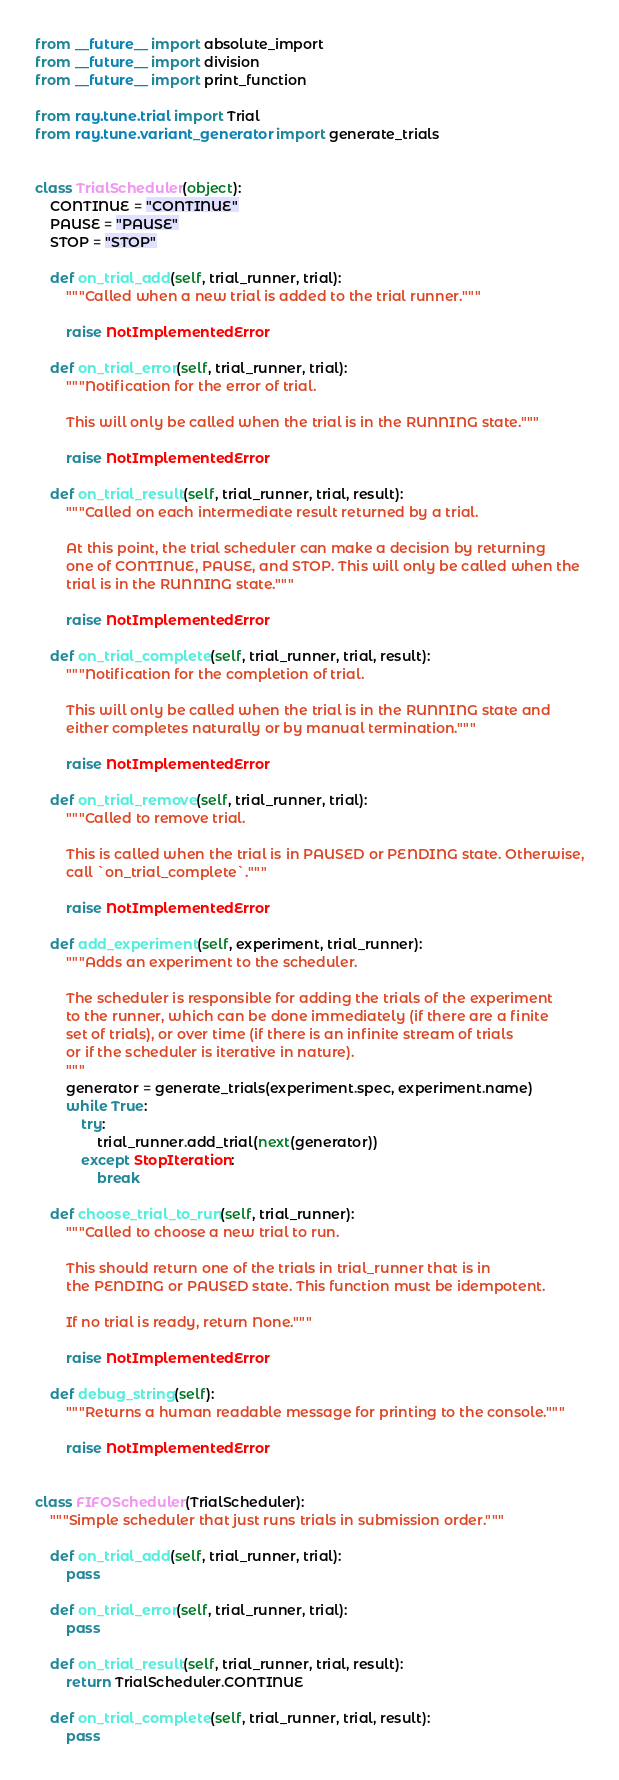<code> <loc_0><loc_0><loc_500><loc_500><_Python_>from __future__ import absolute_import
from __future__ import division
from __future__ import print_function

from ray.tune.trial import Trial
from ray.tune.variant_generator import generate_trials


class TrialScheduler(object):
    CONTINUE = "CONTINUE"
    PAUSE = "PAUSE"
    STOP = "STOP"

    def on_trial_add(self, trial_runner, trial):
        """Called when a new trial is added to the trial runner."""

        raise NotImplementedError

    def on_trial_error(self, trial_runner, trial):
        """Notification for the error of trial.

        This will only be called when the trial is in the RUNNING state."""

        raise NotImplementedError

    def on_trial_result(self, trial_runner, trial, result):
        """Called on each intermediate result returned by a trial.

        At this point, the trial scheduler can make a decision by returning
        one of CONTINUE, PAUSE, and STOP. This will only be called when the
        trial is in the RUNNING state."""

        raise NotImplementedError

    def on_trial_complete(self, trial_runner, trial, result):
        """Notification for the completion of trial.

        This will only be called when the trial is in the RUNNING state and
        either completes naturally or by manual termination."""

        raise NotImplementedError

    def on_trial_remove(self, trial_runner, trial):
        """Called to remove trial.

        This is called when the trial is in PAUSED or PENDING state. Otherwise,
        call `on_trial_complete`."""

        raise NotImplementedError

    def add_experiment(self, experiment, trial_runner):
        """Adds an experiment to the scheduler.

        The scheduler is responsible for adding the trials of the experiment
        to the runner, which can be done immediately (if there are a finite
        set of trials), or over time (if there is an infinite stream of trials
        or if the scheduler is iterative in nature).
        """
        generator = generate_trials(experiment.spec, experiment.name)
        while True:
            try:
                trial_runner.add_trial(next(generator))
            except StopIteration:
                break

    def choose_trial_to_run(self, trial_runner):
        """Called to choose a new trial to run.

        This should return one of the trials in trial_runner that is in
        the PENDING or PAUSED state. This function must be idempotent.

        If no trial is ready, return None."""

        raise NotImplementedError

    def debug_string(self):
        """Returns a human readable message for printing to the console."""

        raise NotImplementedError


class FIFOScheduler(TrialScheduler):
    """Simple scheduler that just runs trials in submission order."""

    def on_trial_add(self, trial_runner, trial):
        pass

    def on_trial_error(self, trial_runner, trial):
        pass

    def on_trial_result(self, trial_runner, trial, result):
        return TrialScheduler.CONTINUE

    def on_trial_complete(self, trial_runner, trial, result):
        pass
</code> 